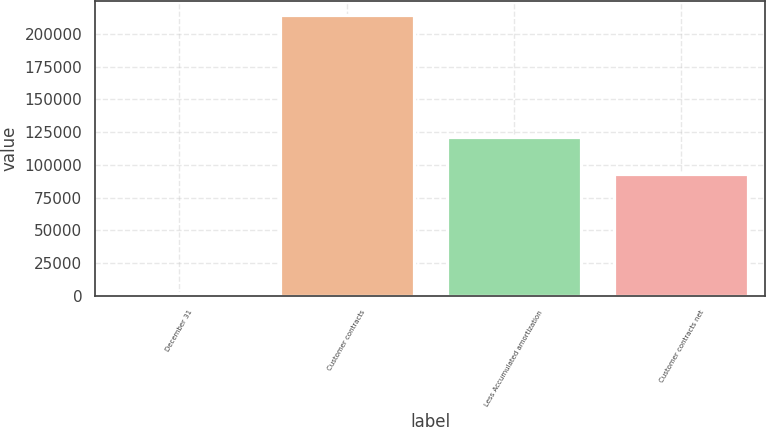Convert chart to OTSL. <chart><loc_0><loc_0><loc_500><loc_500><bar_chart><fcel>December 31<fcel>Customer contracts<fcel>Less Accumulated amortization<fcel>Customer contracts net<nl><fcel>2015<fcel>214201<fcel>121386<fcel>92815<nl></chart> 